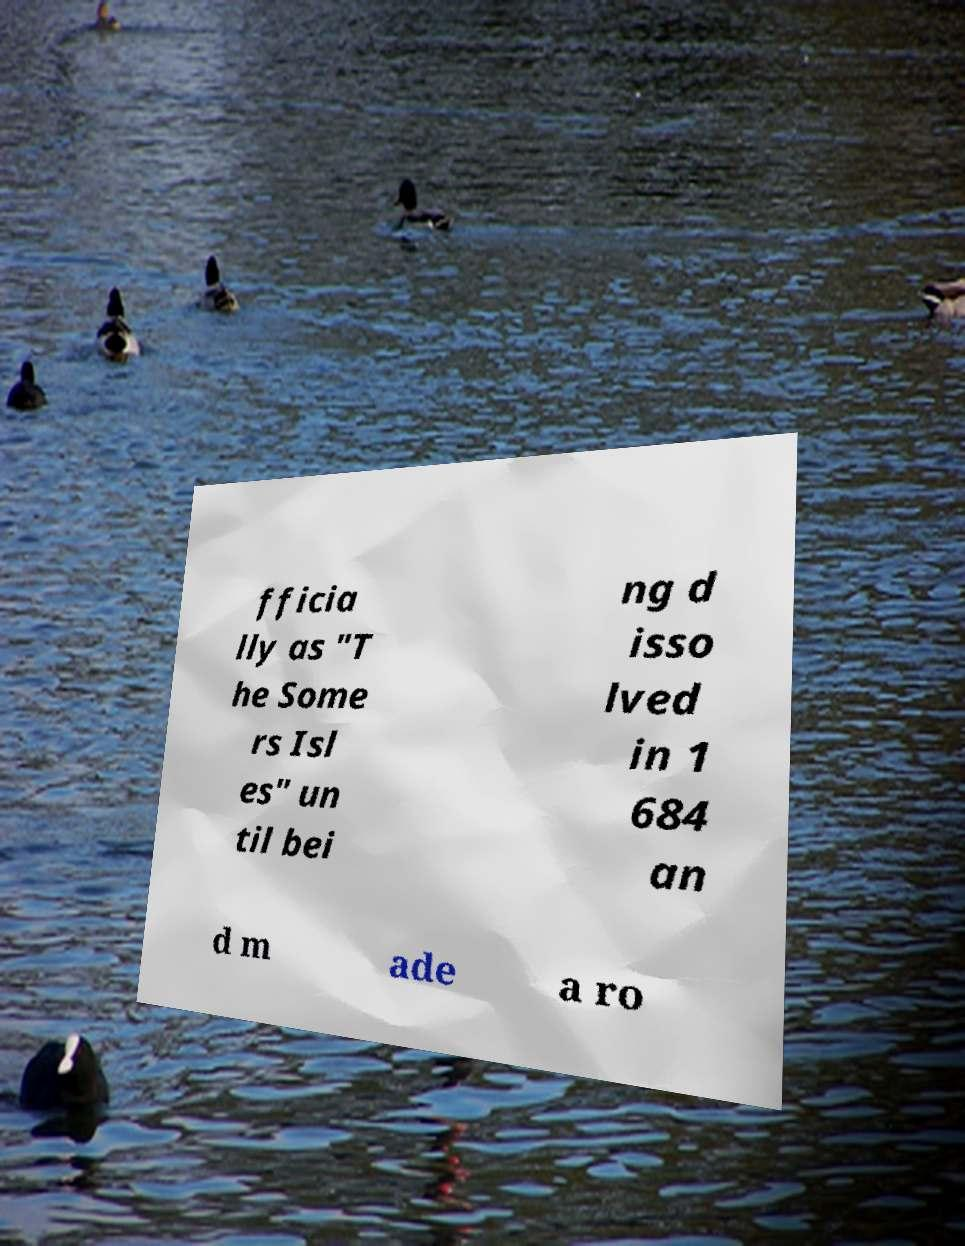For documentation purposes, I need the text within this image transcribed. Could you provide that? fficia lly as "T he Some rs Isl es" un til bei ng d isso lved in 1 684 an d m ade a ro 